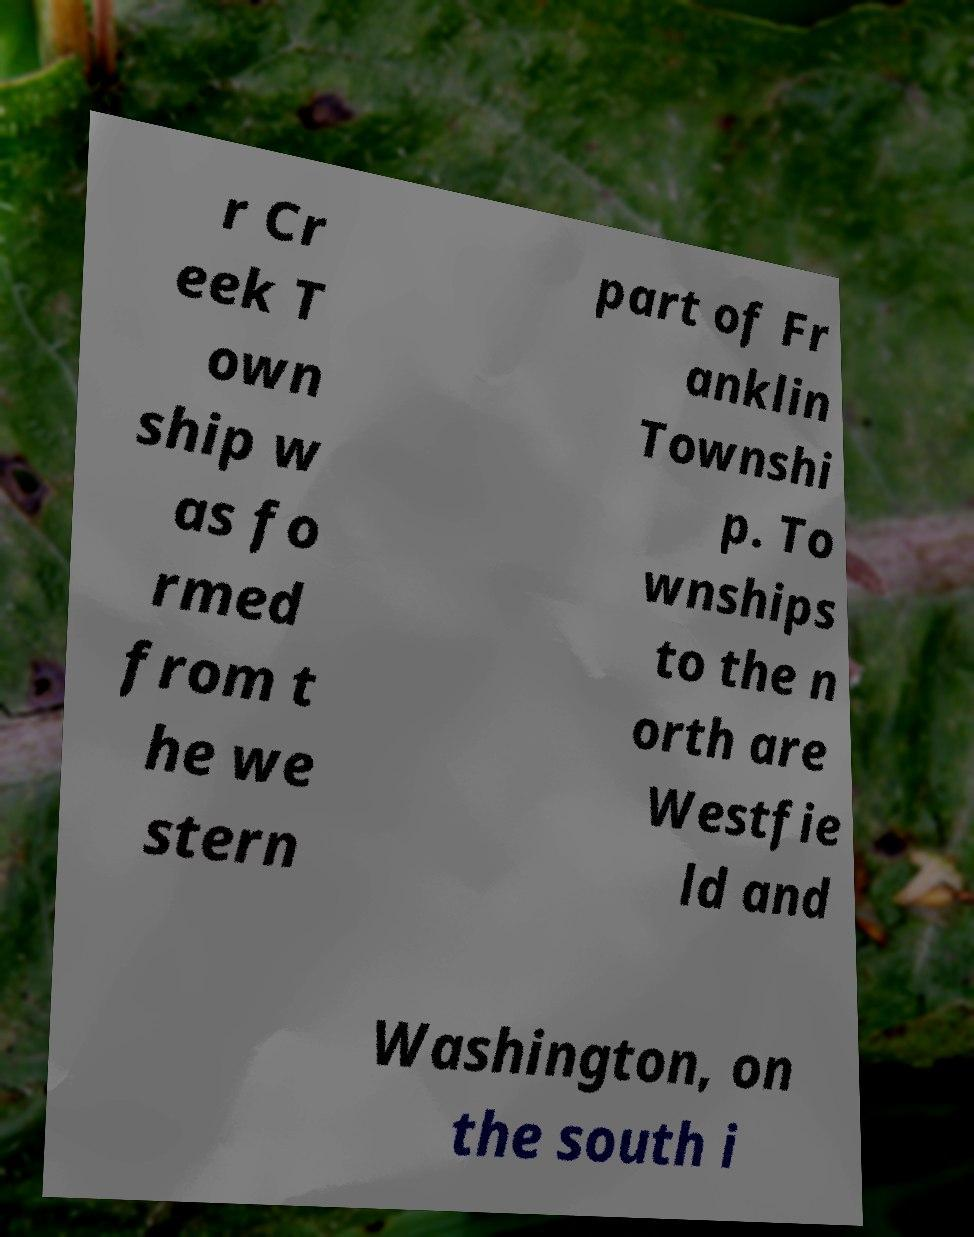Please read and relay the text visible in this image. What does it say? r Cr eek T own ship w as fo rmed from t he we stern part of Fr anklin Townshi p. To wnships to the n orth are Westfie ld and Washington, on the south i 